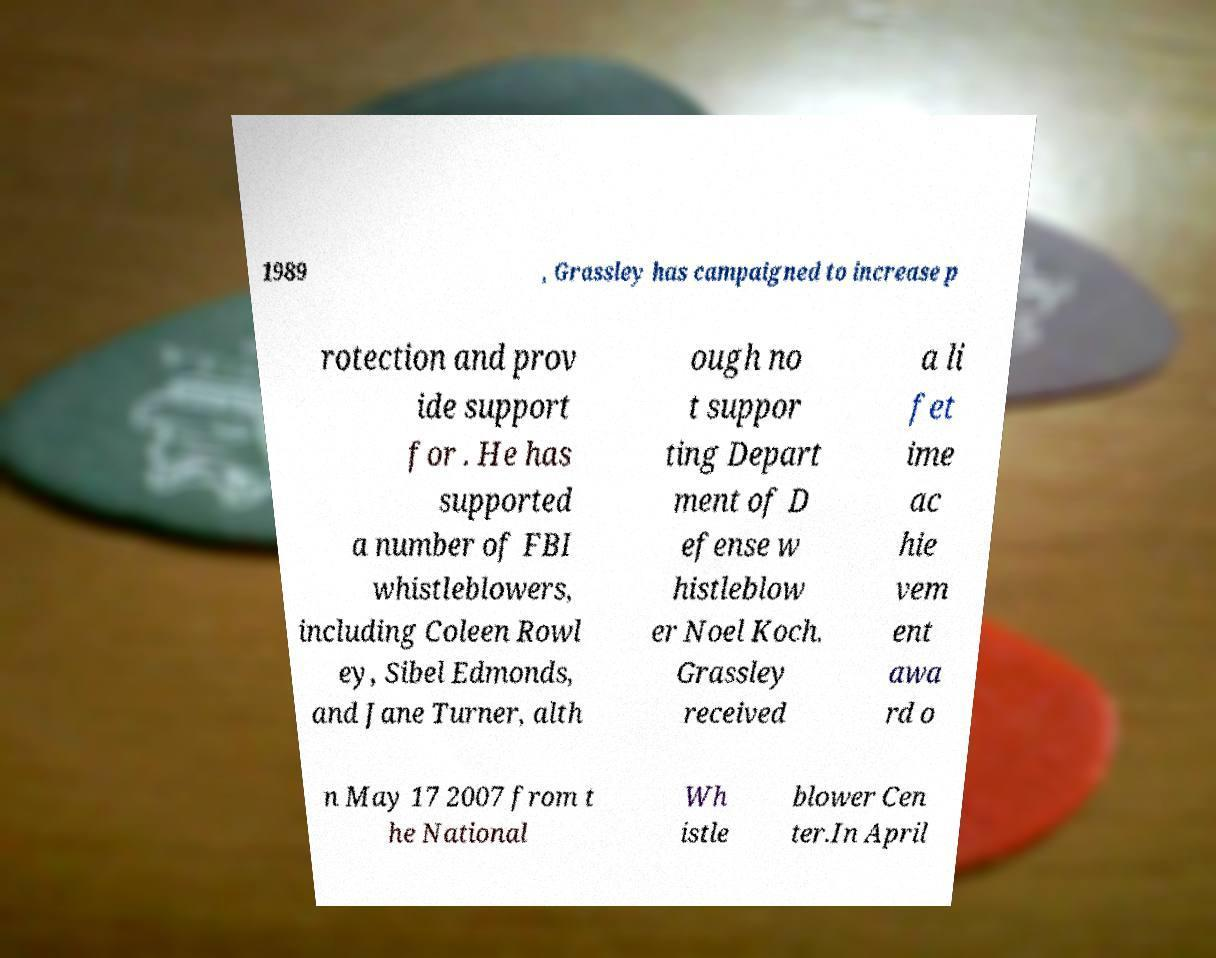Please identify and transcribe the text found in this image. 1989 , Grassley has campaigned to increase p rotection and prov ide support for . He has supported a number of FBI whistleblowers, including Coleen Rowl ey, Sibel Edmonds, and Jane Turner, alth ough no t suppor ting Depart ment of D efense w histleblow er Noel Koch. Grassley received a li fet ime ac hie vem ent awa rd o n May 17 2007 from t he National Wh istle blower Cen ter.In April 